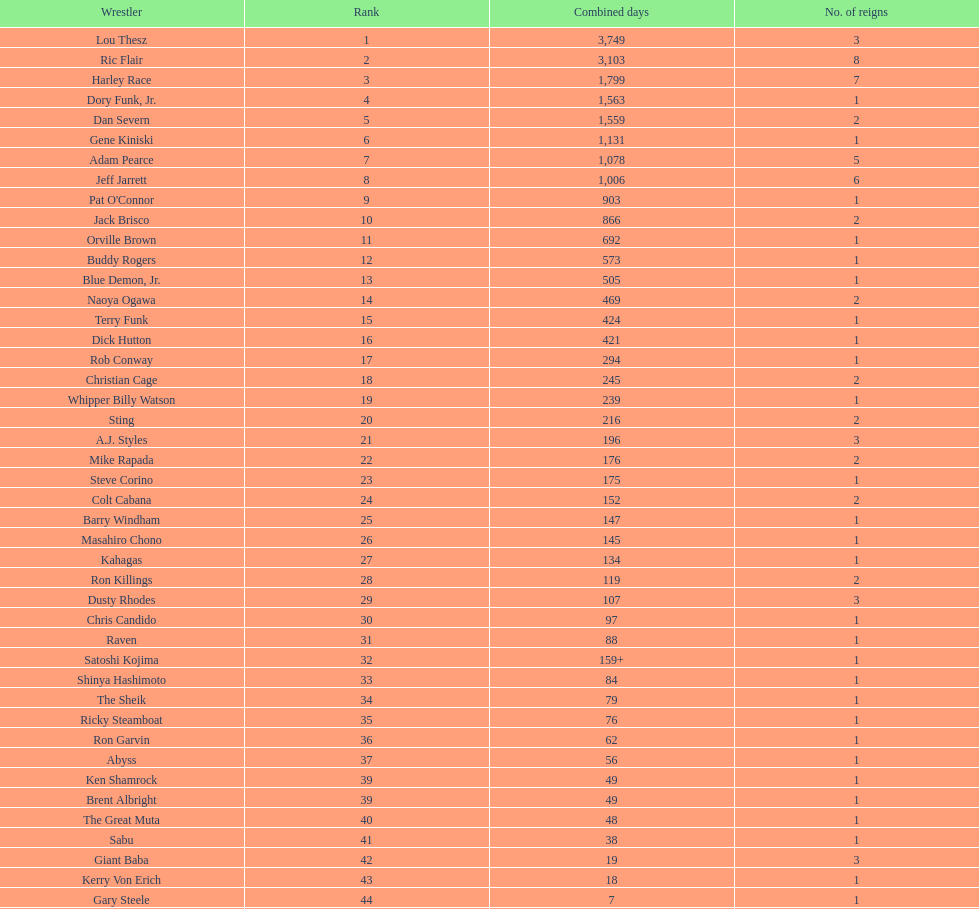How long did orville brown remain nwa world heavyweight champion? 692 days. 